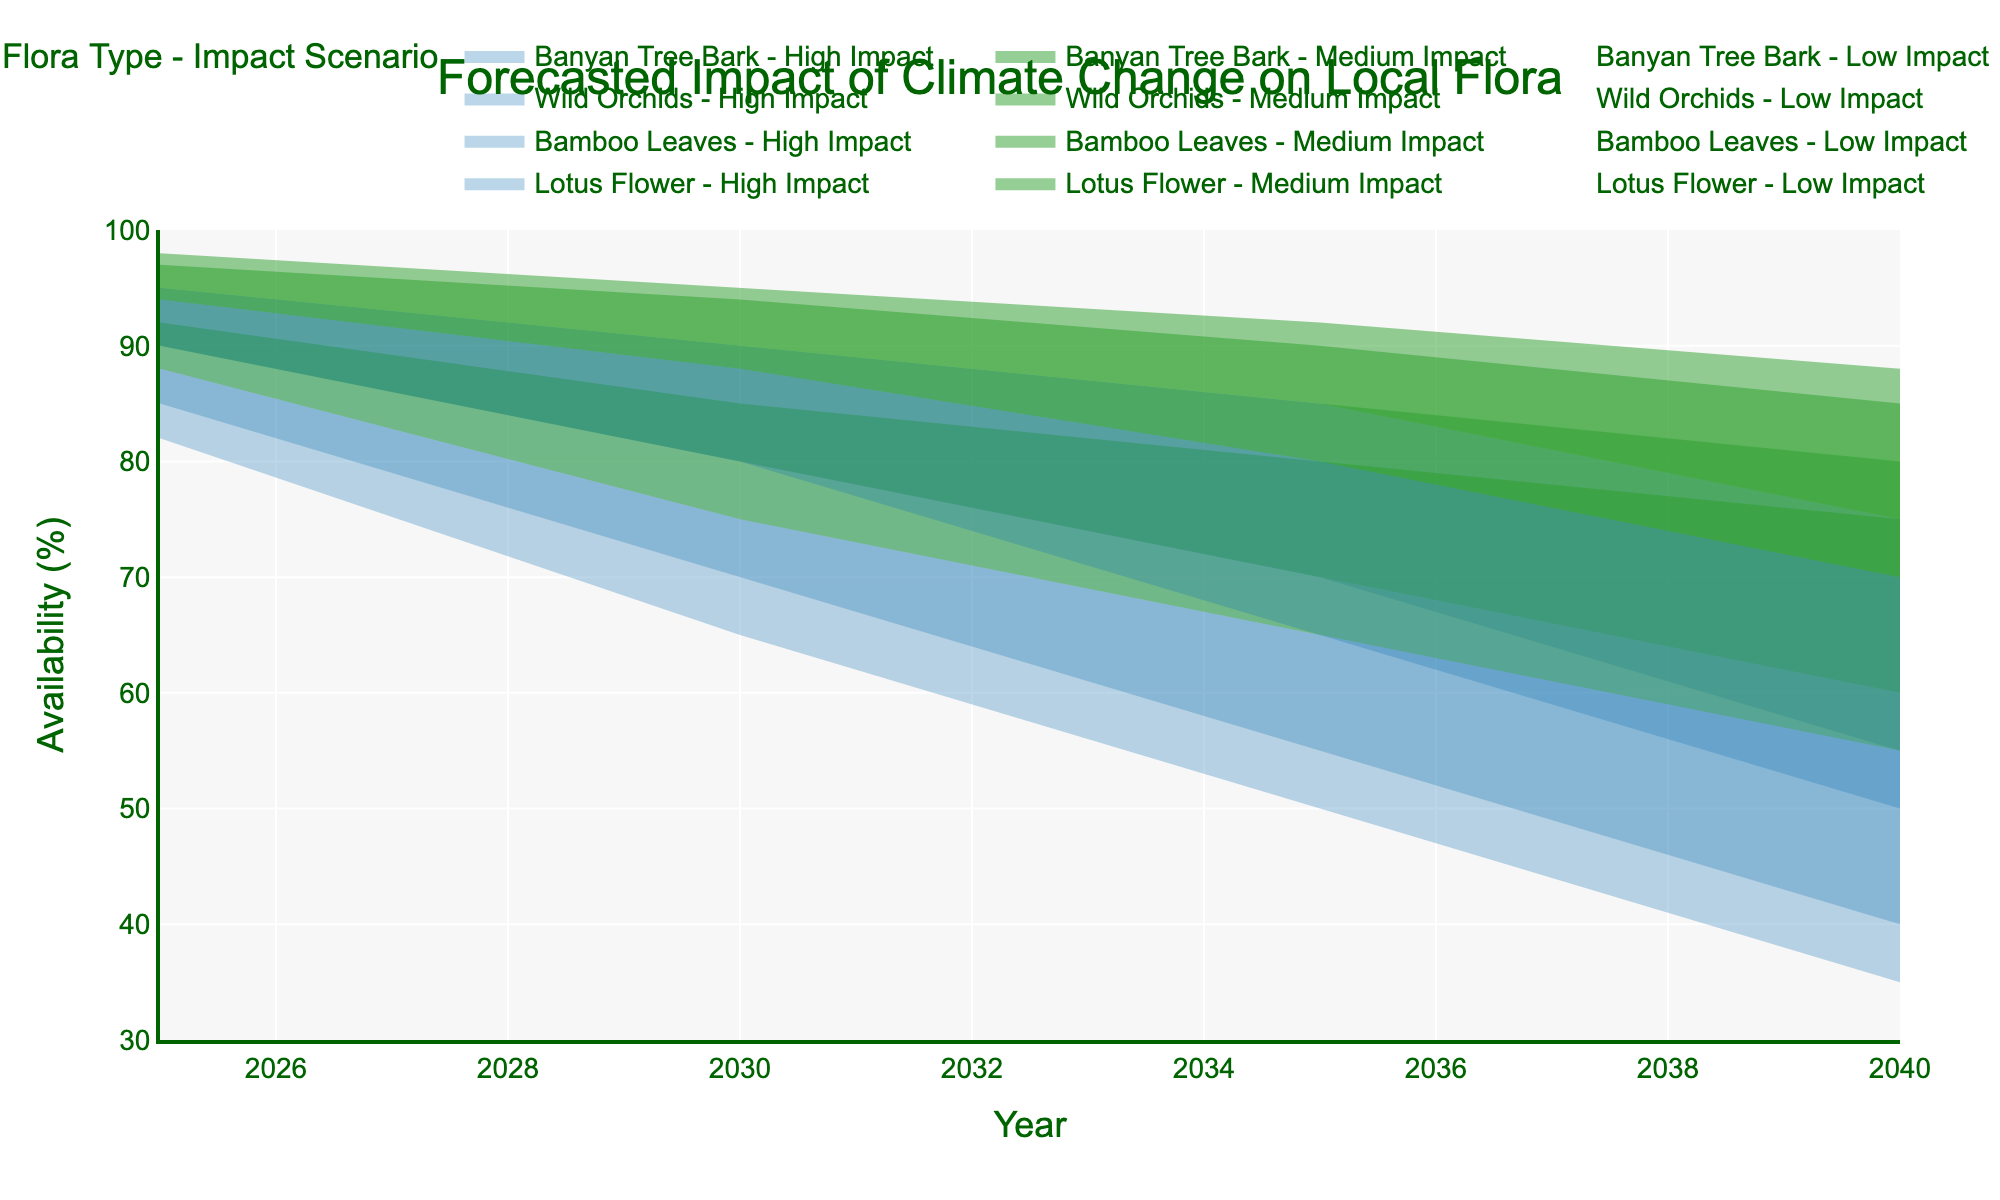How many different scenarios are represented in the figure? The figure represents three different scenarios: Low Impact, Medium Impact, and High Impact, denoted by varying shades in the plot.
Answer: Three What is the availability of Bamboo Leaves in 2040 under the Low Impact scenario? By looking at the plot for Bamboo Leaves under the Low Impact scenario section, we can see that the data point for 2040 is at 88%.
Answer: 88% Which flora type shows the largest decrease in availability from 2025 to 2040 under the High Impact scenario? Comparing the data points for all flora types under the High Impact scenario from 2025 to 2040, Wild Orchids show the largest decrease from 82% to 35%, a difference of 47%.
Answer: Wild Orchids What is the average projected availability of Lotus Flower in 2030 across all scenarios? The data points for Lotus Flower in 2030 are 90% (Low Impact), 80% (Medium Impact), and 70% (High Impact). The average is (90 + 80 + 70) / 3 = 80%.
Answer: 80% Which year has the highest availability of Wild Orchids under the Medium Impact scenario? Looking at the plot, we find that 2025 has the highest availability for Wild Orchids in the Medium Impact scenario with a value of 88%.
Answer: 2025 Between Bamboo Leaves and Banyan Tree Bark, which one is expected to have a higher availability in 2035 under the Medium Impact scenario? By examining the plot, Bamboo Leaves has a projected availability of 85% in 2035 under the Medium Impact scenario, while Banyan Tree Bark has 80%. Therefore, Bamboo Leaves are higher.
Answer: Bamboo Leaves In which impact scenario does Banyan Tree Bark maintain the highest availability in 2030? The Low Impact scenario shows the highest availability for Banyan Tree Bark in 2030 at 94%.
Answer: Low Impact How does the availability of Lotus Flowers in 2040 under the High Impact scenario compare to the availability in 2025 under the Medium Impact scenario? In 2040 under the High Impact scenario, Lotus Flowers are at 40%. In 2025 under the Medium Impact scenario, they are at 90%. The availability is higher in 2025 under the Medium Impact scenario.
Answer: Higher in 2025 Medium Impact Calculate the percentage decrease of Lotus Flowers from 2025 to 2040 in the High Impact scenario. The availability of Lotus Flowers in 2025 is 85% and in 2040 it is 40%, under the High Impact scenario. The decrease is (85 - 40) / 85 * 100% = 52.94%.
Answer: 52.94% Which flora type in the Low Impact scenario shows the smallest decrease in availability from 2025 to 2040? By examining the plot for all flora types under the Low Impact scenario, we see that Bamboo Leaves decrease from 98% in 2025 to 88% in 2040, which is the smallest decrease of 10%.
Answer: Bamboo Leaves 